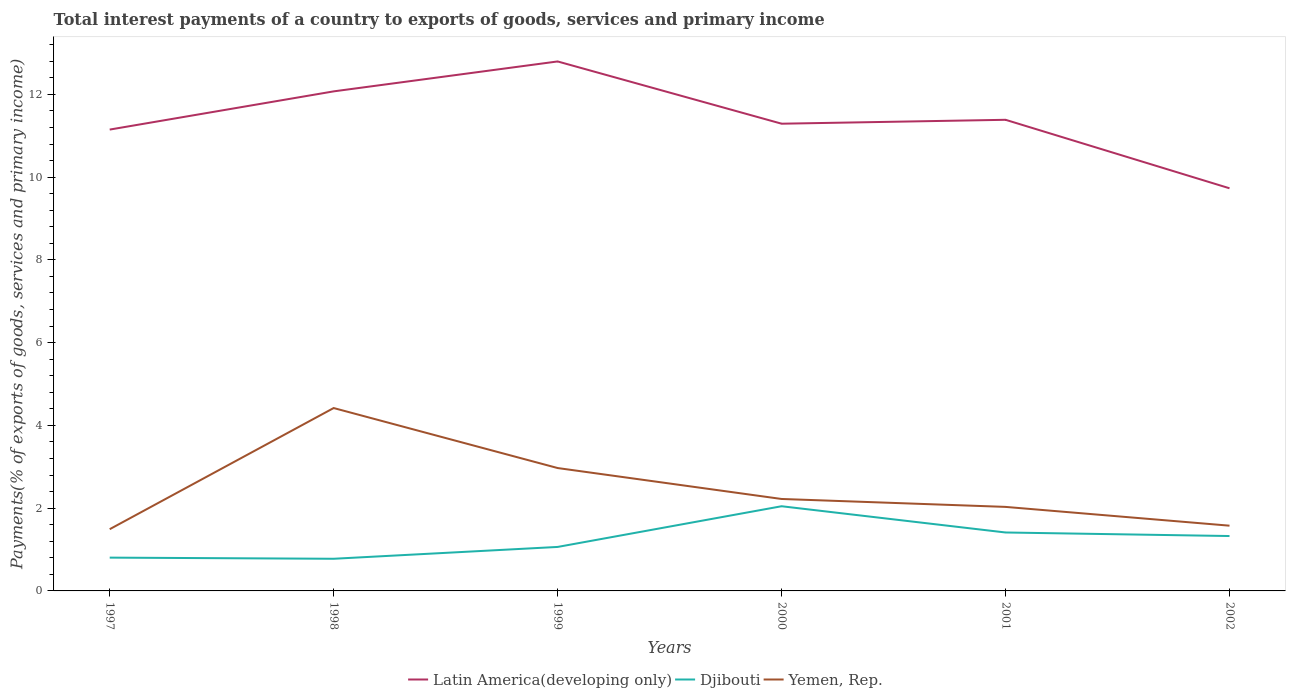Across all years, what is the maximum total interest payments in Latin America(developing only)?
Give a very brief answer. 9.73. What is the total total interest payments in Latin America(developing only) in the graph?
Provide a short and direct response. 1.42. What is the difference between the highest and the second highest total interest payments in Yemen, Rep.?
Your response must be concise. 2.93. How many lines are there?
Your answer should be very brief. 3. How many years are there in the graph?
Your answer should be very brief. 6. Does the graph contain any zero values?
Give a very brief answer. No. Does the graph contain grids?
Provide a succinct answer. No. How many legend labels are there?
Keep it short and to the point. 3. How are the legend labels stacked?
Give a very brief answer. Horizontal. What is the title of the graph?
Offer a very short reply. Total interest payments of a country to exports of goods, services and primary income. Does "Jordan" appear as one of the legend labels in the graph?
Your response must be concise. No. What is the label or title of the X-axis?
Ensure brevity in your answer.  Years. What is the label or title of the Y-axis?
Your answer should be compact. Payments(% of exports of goods, services and primary income). What is the Payments(% of exports of goods, services and primary income) in Latin America(developing only) in 1997?
Provide a short and direct response. 11.15. What is the Payments(% of exports of goods, services and primary income) in Djibouti in 1997?
Provide a succinct answer. 0.8. What is the Payments(% of exports of goods, services and primary income) in Yemen, Rep. in 1997?
Your response must be concise. 1.49. What is the Payments(% of exports of goods, services and primary income) in Latin America(developing only) in 1998?
Provide a short and direct response. 12.07. What is the Payments(% of exports of goods, services and primary income) in Djibouti in 1998?
Offer a very short reply. 0.78. What is the Payments(% of exports of goods, services and primary income) of Yemen, Rep. in 1998?
Make the answer very short. 4.42. What is the Payments(% of exports of goods, services and primary income) of Latin America(developing only) in 1999?
Offer a very short reply. 12.8. What is the Payments(% of exports of goods, services and primary income) of Djibouti in 1999?
Your answer should be compact. 1.06. What is the Payments(% of exports of goods, services and primary income) of Yemen, Rep. in 1999?
Provide a succinct answer. 2.97. What is the Payments(% of exports of goods, services and primary income) in Latin America(developing only) in 2000?
Provide a succinct answer. 11.29. What is the Payments(% of exports of goods, services and primary income) in Djibouti in 2000?
Provide a short and direct response. 2.05. What is the Payments(% of exports of goods, services and primary income) of Yemen, Rep. in 2000?
Offer a very short reply. 2.22. What is the Payments(% of exports of goods, services and primary income) of Latin America(developing only) in 2001?
Your answer should be compact. 11.39. What is the Payments(% of exports of goods, services and primary income) of Djibouti in 2001?
Offer a very short reply. 1.41. What is the Payments(% of exports of goods, services and primary income) of Yemen, Rep. in 2001?
Make the answer very short. 2.03. What is the Payments(% of exports of goods, services and primary income) of Latin America(developing only) in 2002?
Make the answer very short. 9.73. What is the Payments(% of exports of goods, services and primary income) of Djibouti in 2002?
Your response must be concise. 1.33. What is the Payments(% of exports of goods, services and primary income) of Yemen, Rep. in 2002?
Offer a very short reply. 1.58. Across all years, what is the maximum Payments(% of exports of goods, services and primary income) of Latin America(developing only)?
Give a very brief answer. 12.8. Across all years, what is the maximum Payments(% of exports of goods, services and primary income) in Djibouti?
Your answer should be very brief. 2.05. Across all years, what is the maximum Payments(% of exports of goods, services and primary income) of Yemen, Rep.?
Offer a terse response. 4.42. Across all years, what is the minimum Payments(% of exports of goods, services and primary income) in Latin America(developing only)?
Offer a very short reply. 9.73. Across all years, what is the minimum Payments(% of exports of goods, services and primary income) of Djibouti?
Keep it short and to the point. 0.78. Across all years, what is the minimum Payments(% of exports of goods, services and primary income) of Yemen, Rep.?
Keep it short and to the point. 1.49. What is the total Payments(% of exports of goods, services and primary income) of Latin America(developing only) in the graph?
Provide a short and direct response. 68.42. What is the total Payments(% of exports of goods, services and primary income) in Djibouti in the graph?
Give a very brief answer. 7.43. What is the total Payments(% of exports of goods, services and primary income) of Yemen, Rep. in the graph?
Provide a short and direct response. 14.71. What is the difference between the Payments(% of exports of goods, services and primary income) in Latin America(developing only) in 1997 and that in 1998?
Make the answer very short. -0.92. What is the difference between the Payments(% of exports of goods, services and primary income) of Djibouti in 1997 and that in 1998?
Ensure brevity in your answer.  0.03. What is the difference between the Payments(% of exports of goods, services and primary income) of Yemen, Rep. in 1997 and that in 1998?
Make the answer very short. -2.93. What is the difference between the Payments(% of exports of goods, services and primary income) of Latin America(developing only) in 1997 and that in 1999?
Provide a short and direct response. -1.65. What is the difference between the Payments(% of exports of goods, services and primary income) in Djibouti in 1997 and that in 1999?
Provide a short and direct response. -0.26. What is the difference between the Payments(% of exports of goods, services and primary income) of Yemen, Rep. in 1997 and that in 1999?
Offer a terse response. -1.48. What is the difference between the Payments(% of exports of goods, services and primary income) in Latin America(developing only) in 1997 and that in 2000?
Provide a short and direct response. -0.14. What is the difference between the Payments(% of exports of goods, services and primary income) in Djibouti in 1997 and that in 2000?
Your response must be concise. -1.24. What is the difference between the Payments(% of exports of goods, services and primary income) in Yemen, Rep. in 1997 and that in 2000?
Your answer should be compact. -0.73. What is the difference between the Payments(% of exports of goods, services and primary income) of Latin America(developing only) in 1997 and that in 2001?
Make the answer very short. -0.24. What is the difference between the Payments(% of exports of goods, services and primary income) in Djibouti in 1997 and that in 2001?
Give a very brief answer. -0.61. What is the difference between the Payments(% of exports of goods, services and primary income) of Yemen, Rep. in 1997 and that in 2001?
Provide a succinct answer. -0.54. What is the difference between the Payments(% of exports of goods, services and primary income) in Latin America(developing only) in 1997 and that in 2002?
Keep it short and to the point. 1.42. What is the difference between the Payments(% of exports of goods, services and primary income) in Djibouti in 1997 and that in 2002?
Ensure brevity in your answer.  -0.52. What is the difference between the Payments(% of exports of goods, services and primary income) of Yemen, Rep. in 1997 and that in 2002?
Your answer should be very brief. -0.08. What is the difference between the Payments(% of exports of goods, services and primary income) of Latin America(developing only) in 1998 and that in 1999?
Give a very brief answer. -0.72. What is the difference between the Payments(% of exports of goods, services and primary income) in Djibouti in 1998 and that in 1999?
Your answer should be very brief. -0.29. What is the difference between the Payments(% of exports of goods, services and primary income) in Yemen, Rep. in 1998 and that in 1999?
Your response must be concise. 1.45. What is the difference between the Payments(% of exports of goods, services and primary income) in Latin America(developing only) in 1998 and that in 2000?
Your response must be concise. 0.78. What is the difference between the Payments(% of exports of goods, services and primary income) in Djibouti in 1998 and that in 2000?
Your response must be concise. -1.27. What is the difference between the Payments(% of exports of goods, services and primary income) in Yemen, Rep. in 1998 and that in 2000?
Offer a very short reply. 2.2. What is the difference between the Payments(% of exports of goods, services and primary income) of Latin America(developing only) in 1998 and that in 2001?
Your response must be concise. 0.69. What is the difference between the Payments(% of exports of goods, services and primary income) of Djibouti in 1998 and that in 2001?
Your answer should be very brief. -0.64. What is the difference between the Payments(% of exports of goods, services and primary income) in Yemen, Rep. in 1998 and that in 2001?
Your response must be concise. 2.39. What is the difference between the Payments(% of exports of goods, services and primary income) of Latin America(developing only) in 1998 and that in 2002?
Your response must be concise. 2.34. What is the difference between the Payments(% of exports of goods, services and primary income) of Djibouti in 1998 and that in 2002?
Make the answer very short. -0.55. What is the difference between the Payments(% of exports of goods, services and primary income) in Yemen, Rep. in 1998 and that in 2002?
Your answer should be very brief. 2.84. What is the difference between the Payments(% of exports of goods, services and primary income) in Latin America(developing only) in 1999 and that in 2000?
Keep it short and to the point. 1.5. What is the difference between the Payments(% of exports of goods, services and primary income) of Djibouti in 1999 and that in 2000?
Your answer should be very brief. -0.98. What is the difference between the Payments(% of exports of goods, services and primary income) in Yemen, Rep. in 1999 and that in 2000?
Make the answer very short. 0.75. What is the difference between the Payments(% of exports of goods, services and primary income) in Latin America(developing only) in 1999 and that in 2001?
Provide a short and direct response. 1.41. What is the difference between the Payments(% of exports of goods, services and primary income) of Djibouti in 1999 and that in 2001?
Provide a succinct answer. -0.35. What is the difference between the Payments(% of exports of goods, services and primary income) of Yemen, Rep. in 1999 and that in 2001?
Your answer should be very brief. 0.94. What is the difference between the Payments(% of exports of goods, services and primary income) in Latin America(developing only) in 1999 and that in 2002?
Give a very brief answer. 3.07. What is the difference between the Payments(% of exports of goods, services and primary income) of Djibouti in 1999 and that in 2002?
Offer a terse response. -0.26. What is the difference between the Payments(% of exports of goods, services and primary income) in Yemen, Rep. in 1999 and that in 2002?
Offer a terse response. 1.39. What is the difference between the Payments(% of exports of goods, services and primary income) of Latin America(developing only) in 2000 and that in 2001?
Provide a succinct answer. -0.09. What is the difference between the Payments(% of exports of goods, services and primary income) of Djibouti in 2000 and that in 2001?
Offer a terse response. 0.63. What is the difference between the Payments(% of exports of goods, services and primary income) of Yemen, Rep. in 2000 and that in 2001?
Provide a succinct answer. 0.19. What is the difference between the Payments(% of exports of goods, services and primary income) in Latin America(developing only) in 2000 and that in 2002?
Make the answer very short. 1.56. What is the difference between the Payments(% of exports of goods, services and primary income) of Djibouti in 2000 and that in 2002?
Provide a succinct answer. 0.72. What is the difference between the Payments(% of exports of goods, services and primary income) in Yemen, Rep. in 2000 and that in 2002?
Your response must be concise. 0.65. What is the difference between the Payments(% of exports of goods, services and primary income) in Latin America(developing only) in 2001 and that in 2002?
Give a very brief answer. 1.66. What is the difference between the Payments(% of exports of goods, services and primary income) of Djibouti in 2001 and that in 2002?
Your answer should be compact. 0.09. What is the difference between the Payments(% of exports of goods, services and primary income) of Yemen, Rep. in 2001 and that in 2002?
Provide a short and direct response. 0.45. What is the difference between the Payments(% of exports of goods, services and primary income) in Latin America(developing only) in 1997 and the Payments(% of exports of goods, services and primary income) in Djibouti in 1998?
Make the answer very short. 10.37. What is the difference between the Payments(% of exports of goods, services and primary income) in Latin America(developing only) in 1997 and the Payments(% of exports of goods, services and primary income) in Yemen, Rep. in 1998?
Offer a very short reply. 6.73. What is the difference between the Payments(% of exports of goods, services and primary income) of Djibouti in 1997 and the Payments(% of exports of goods, services and primary income) of Yemen, Rep. in 1998?
Your answer should be compact. -3.61. What is the difference between the Payments(% of exports of goods, services and primary income) in Latin America(developing only) in 1997 and the Payments(% of exports of goods, services and primary income) in Djibouti in 1999?
Provide a succinct answer. 10.09. What is the difference between the Payments(% of exports of goods, services and primary income) in Latin America(developing only) in 1997 and the Payments(% of exports of goods, services and primary income) in Yemen, Rep. in 1999?
Give a very brief answer. 8.18. What is the difference between the Payments(% of exports of goods, services and primary income) in Djibouti in 1997 and the Payments(% of exports of goods, services and primary income) in Yemen, Rep. in 1999?
Give a very brief answer. -2.16. What is the difference between the Payments(% of exports of goods, services and primary income) in Latin America(developing only) in 1997 and the Payments(% of exports of goods, services and primary income) in Djibouti in 2000?
Keep it short and to the point. 9.1. What is the difference between the Payments(% of exports of goods, services and primary income) in Latin America(developing only) in 1997 and the Payments(% of exports of goods, services and primary income) in Yemen, Rep. in 2000?
Give a very brief answer. 8.93. What is the difference between the Payments(% of exports of goods, services and primary income) of Djibouti in 1997 and the Payments(% of exports of goods, services and primary income) of Yemen, Rep. in 2000?
Offer a terse response. -1.42. What is the difference between the Payments(% of exports of goods, services and primary income) in Latin America(developing only) in 1997 and the Payments(% of exports of goods, services and primary income) in Djibouti in 2001?
Give a very brief answer. 9.74. What is the difference between the Payments(% of exports of goods, services and primary income) in Latin America(developing only) in 1997 and the Payments(% of exports of goods, services and primary income) in Yemen, Rep. in 2001?
Give a very brief answer. 9.12. What is the difference between the Payments(% of exports of goods, services and primary income) in Djibouti in 1997 and the Payments(% of exports of goods, services and primary income) in Yemen, Rep. in 2001?
Make the answer very short. -1.23. What is the difference between the Payments(% of exports of goods, services and primary income) of Latin America(developing only) in 1997 and the Payments(% of exports of goods, services and primary income) of Djibouti in 2002?
Your answer should be very brief. 9.82. What is the difference between the Payments(% of exports of goods, services and primary income) in Latin America(developing only) in 1997 and the Payments(% of exports of goods, services and primary income) in Yemen, Rep. in 2002?
Provide a short and direct response. 9.57. What is the difference between the Payments(% of exports of goods, services and primary income) in Djibouti in 1997 and the Payments(% of exports of goods, services and primary income) in Yemen, Rep. in 2002?
Offer a terse response. -0.77. What is the difference between the Payments(% of exports of goods, services and primary income) in Latin America(developing only) in 1998 and the Payments(% of exports of goods, services and primary income) in Djibouti in 1999?
Keep it short and to the point. 11.01. What is the difference between the Payments(% of exports of goods, services and primary income) of Latin America(developing only) in 1998 and the Payments(% of exports of goods, services and primary income) of Yemen, Rep. in 1999?
Give a very brief answer. 9.1. What is the difference between the Payments(% of exports of goods, services and primary income) of Djibouti in 1998 and the Payments(% of exports of goods, services and primary income) of Yemen, Rep. in 1999?
Offer a terse response. -2.19. What is the difference between the Payments(% of exports of goods, services and primary income) in Latin America(developing only) in 1998 and the Payments(% of exports of goods, services and primary income) in Djibouti in 2000?
Your answer should be very brief. 10.03. What is the difference between the Payments(% of exports of goods, services and primary income) of Latin America(developing only) in 1998 and the Payments(% of exports of goods, services and primary income) of Yemen, Rep. in 2000?
Make the answer very short. 9.85. What is the difference between the Payments(% of exports of goods, services and primary income) of Djibouti in 1998 and the Payments(% of exports of goods, services and primary income) of Yemen, Rep. in 2000?
Keep it short and to the point. -1.45. What is the difference between the Payments(% of exports of goods, services and primary income) of Latin America(developing only) in 1998 and the Payments(% of exports of goods, services and primary income) of Djibouti in 2001?
Offer a terse response. 10.66. What is the difference between the Payments(% of exports of goods, services and primary income) in Latin America(developing only) in 1998 and the Payments(% of exports of goods, services and primary income) in Yemen, Rep. in 2001?
Make the answer very short. 10.04. What is the difference between the Payments(% of exports of goods, services and primary income) of Djibouti in 1998 and the Payments(% of exports of goods, services and primary income) of Yemen, Rep. in 2001?
Your response must be concise. -1.25. What is the difference between the Payments(% of exports of goods, services and primary income) in Latin America(developing only) in 1998 and the Payments(% of exports of goods, services and primary income) in Djibouti in 2002?
Keep it short and to the point. 10.75. What is the difference between the Payments(% of exports of goods, services and primary income) of Latin America(developing only) in 1998 and the Payments(% of exports of goods, services and primary income) of Yemen, Rep. in 2002?
Offer a very short reply. 10.5. What is the difference between the Payments(% of exports of goods, services and primary income) of Djibouti in 1998 and the Payments(% of exports of goods, services and primary income) of Yemen, Rep. in 2002?
Offer a very short reply. -0.8. What is the difference between the Payments(% of exports of goods, services and primary income) of Latin America(developing only) in 1999 and the Payments(% of exports of goods, services and primary income) of Djibouti in 2000?
Make the answer very short. 10.75. What is the difference between the Payments(% of exports of goods, services and primary income) of Latin America(developing only) in 1999 and the Payments(% of exports of goods, services and primary income) of Yemen, Rep. in 2000?
Ensure brevity in your answer.  10.57. What is the difference between the Payments(% of exports of goods, services and primary income) of Djibouti in 1999 and the Payments(% of exports of goods, services and primary income) of Yemen, Rep. in 2000?
Provide a succinct answer. -1.16. What is the difference between the Payments(% of exports of goods, services and primary income) of Latin America(developing only) in 1999 and the Payments(% of exports of goods, services and primary income) of Djibouti in 2001?
Your answer should be very brief. 11.38. What is the difference between the Payments(% of exports of goods, services and primary income) in Latin America(developing only) in 1999 and the Payments(% of exports of goods, services and primary income) in Yemen, Rep. in 2001?
Ensure brevity in your answer.  10.76. What is the difference between the Payments(% of exports of goods, services and primary income) in Djibouti in 1999 and the Payments(% of exports of goods, services and primary income) in Yemen, Rep. in 2001?
Offer a terse response. -0.97. What is the difference between the Payments(% of exports of goods, services and primary income) of Latin America(developing only) in 1999 and the Payments(% of exports of goods, services and primary income) of Djibouti in 2002?
Offer a terse response. 11.47. What is the difference between the Payments(% of exports of goods, services and primary income) of Latin America(developing only) in 1999 and the Payments(% of exports of goods, services and primary income) of Yemen, Rep. in 2002?
Your answer should be very brief. 11.22. What is the difference between the Payments(% of exports of goods, services and primary income) in Djibouti in 1999 and the Payments(% of exports of goods, services and primary income) in Yemen, Rep. in 2002?
Offer a terse response. -0.51. What is the difference between the Payments(% of exports of goods, services and primary income) of Latin America(developing only) in 2000 and the Payments(% of exports of goods, services and primary income) of Djibouti in 2001?
Make the answer very short. 9.88. What is the difference between the Payments(% of exports of goods, services and primary income) of Latin America(developing only) in 2000 and the Payments(% of exports of goods, services and primary income) of Yemen, Rep. in 2001?
Your answer should be compact. 9.26. What is the difference between the Payments(% of exports of goods, services and primary income) in Djibouti in 2000 and the Payments(% of exports of goods, services and primary income) in Yemen, Rep. in 2001?
Offer a terse response. 0.02. What is the difference between the Payments(% of exports of goods, services and primary income) of Latin America(developing only) in 2000 and the Payments(% of exports of goods, services and primary income) of Djibouti in 2002?
Ensure brevity in your answer.  9.96. What is the difference between the Payments(% of exports of goods, services and primary income) in Latin America(developing only) in 2000 and the Payments(% of exports of goods, services and primary income) in Yemen, Rep. in 2002?
Keep it short and to the point. 9.71. What is the difference between the Payments(% of exports of goods, services and primary income) of Djibouti in 2000 and the Payments(% of exports of goods, services and primary income) of Yemen, Rep. in 2002?
Offer a very short reply. 0.47. What is the difference between the Payments(% of exports of goods, services and primary income) of Latin America(developing only) in 2001 and the Payments(% of exports of goods, services and primary income) of Djibouti in 2002?
Your answer should be compact. 10.06. What is the difference between the Payments(% of exports of goods, services and primary income) of Latin America(developing only) in 2001 and the Payments(% of exports of goods, services and primary income) of Yemen, Rep. in 2002?
Provide a short and direct response. 9.81. What is the difference between the Payments(% of exports of goods, services and primary income) in Djibouti in 2001 and the Payments(% of exports of goods, services and primary income) in Yemen, Rep. in 2002?
Give a very brief answer. -0.16. What is the average Payments(% of exports of goods, services and primary income) of Latin America(developing only) per year?
Your answer should be very brief. 11.4. What is the average Payments(% of exports of goods, services and primary income) in Djibouti per year?
Provide a succinct answer. 1.24. What is the average Payments(% of exports of goods, services and primary income) in Yemen, Rep. per year?
Your answer should be very brief. 2.45. In the year 1997, what is the difference between the Payments(% of exports of goods, services and primary income) of Latin America(developing only) and Payments(% of exports of goods, services and primary income) of Djibouti?
Your answer should be very brief. 10.34. In the year 1997, what is the difference between the Payments(% of exports of goods, services and primary income) in Latin America(developing only) and Payments(% of exports of goods, services and primary income) in Yemen, Rep.?
Your answer should be very brief. 9.66. In the year 1997, what is the difference between the Payments(% of exports of goods, services and primary income) in Djibouti and Payments(% of exports of goods, services and primary income) in Yemen, Rep.?
Keep it short and to the point. -0.69. In the year 1998, what is the difference between the Payments(% of exports of goods, services and primary income) in Latin America(developing only) and Payments(% of exports of goods, services and primary income) in Djibouti?
Ensure brevity in your answer.  11.3. In the year 1998, what is the difference between the Payments(% of exports of goods, services and primary income) in Latin America(developing only) and Payments(% of exports of goods, services and primary income) in Yemen, Rep.?
Provide a succinct answer. 7.65. In the year 1998, what is the difference between the Payments(% of exports of goods, services and primary income) in Djibouti and Payments(% of exports of goods, services and primary income) in Yemen, Rep.?
Offer a terse response. -3.64. In the year 1999, what is the difference between the Payments(% of exports of goods, services and primary income) of Latin America(developing only) and Payments(% of exports of goods, services and primary income) of Djibouti?
Give a very brief answer. 11.73. In the year 1999, what is the difference between the Payments(% of exports of goods, services and primary income) in Latin America(developing only) and Payments(% of exports of goods, services and primary income) in Yemen, Rep.?
Give a very brief answer. 9.83. In the year 1999, what is the difference between the Payments(% of exports of goods, services and primary income) in Djibouti and Payments(% of exports of goods, services and primary income) in Yemen, Rep.?
Offer a terse response. -1.91. In the year 2000, what is the difference between the Payments(% of exports of goods, services and primary income) of Latin America(developing only) and Payments(% of exports of goods, services and primary income) of Djibouti?
Ensure brevity in your answer.  9.24. In the year 2000, what is the difference between the Payments(% of exports of goods, services and primary income) in Latin America(developing only) and Payments(% of exports of goods, services and primary income) in Yemen, Rep.?
Offer a terse response. 9.07. In the year 2000, what is the difference between the Payments(% of exports of goods, services and primary income) of Djibouti and Payments(% of exports of goods, services and primary income) of Yemen, Rep.?
Keep it short and to the point. -0.18. In the year 2001, what is the difference between the Payments(% of exports of goods, services and primary income) of Latin America(developing only) and Payments(% of exports of goods, services and primary income) of Djibouti?
Your answer should be compact. 9.97. In the year 2001, what is the difference between the Payments(% of exports of goods, services and primary income) in Latin America(developing only) and Payments(% of exports of goods, services and primary income) in Yemen, Rep.?
Your response must be concise. 9.35. In the year 2001, what is the difference between the Payments(% of exports of goods, services and primary income) in Djibouti and Payments(% of exports of goods, services and primary income) in Yemen, Rep.?
Give a very brief answer. -0.62. In the year 2002, what is the difference between the Payments(% of exports of goods, services and primary income) of Latin America(developing only) and Payments(% of exports of goods, services and primary income) of Djibouti?
Your answer should be very brief. 8.4. In the year 2002, what is the difference between the Payments(% of exports of goods, services and primary income) in Latin America(developing only) and Payments(% of exports of goods, services and primary income) in Yemen, Rep.?
Offer a terse response. 8.15. In the year 2002, what is the difference between the Payments(% of exports of goods, services and primary income) of Djibouti and Payments(% of exports of goods, services and primary income) of Yemen, Rep.?
Provide a succinct answer. -0.25. What is the ratio of the Payments(% of exports of goods, services and primary income) of Latin America(developing only) in 1997 to that in 1998?
Offer a very short reply. 0.92. What is the ratio of the Payments(% of exports of goods, services and primary income) of Djibouti in 1997 to that in 1998?
Offer a terse response. 1.04. What is the ratio of the Payments(% of exports of goods, services and primary income) of Yemen, Rep. in 1997 to that in 1998?
Offer a terse response. 0.34. What is the ratio of the Payments(% of exports of goods, services and primary income) in Latin America(developing only) in 1997 to that in 1999?
Ensure brevity in your answer.  0.87. What is the ratio of the Payments(% of exports of goods, services and primary income) of Djibouti in 1997 to that in 1999?
Keep it short and to the point. 0.76. What is the ratio of the Payments(% of exports of goods, services and primary income) in Yemen, Rep. in 1997 to that in 1999?
Keep it short and to the point. 0.5. What is the ratio of the Payments(% of exports of goods, services and primary income) of Latin America(developing only) in 1997 to that in 2000?
Offer a terse response. 0.99. What is the ratio of the Payments(% of exports of goods, services and primary income) of Djibouti in 1997 to that in 2000?
Offer a terse response. 0.39. What is the ratio of the Payments(% of exports of goods, services and primary income) of Yemen, Rep. in 1997 to that in 2000?
Offer a terse response. 0.67. What is the ratio of the Payments(% of exports of goods, services and primary income) in Latin America(developing only) in 1997 to that in 2001?
Provide a succinct answer. 0.98. What is the ratio of the Payments(% of exports of goods, services and primary income) of Djibouti in 1997 to that in 2001?
Provide a succinct answer. 0.57. What is the ratio of the Payments(% of exports of goods, services and primary income) of Yemen, Rep. in 1997 to that in 2001?
Ensure brevity in your answer.  0.73. What is the ratio of the Payments(% of exports of goods, services and primary income) in Latin America(developing only) in 1997 to that in 2002?
Provide a succinct answer. 1.15. What is the ratio of the Payments(% of exports of goods, services and primary income) in Djibouti in 1997 to that in 2002?
Your answer should be very brief. 0.61. What is the ratio of the Payments(% of exports of goods, services and primary income) in Yemen, Rep. in 1997 to that in 2002?
Provide a short and direct response. 0.95. What is the ratio of the Payments(% of exports of goods, services and primary income) of Latin America(developing only) in 1998 to that in 1999?
Give a very brief answer. 0.94. What is the ratio of the Payments(% of exports of goods, services and primary income) of Djibouti in 1998 to that in 1999?
Your answer should be compact. 0.73. What is the ratio of the Payments(% of exports of goods, services and primary income) in Yemen, Rep. in 1998 to that in 1999?
Ensure brevity in your answer.  1.49. What is the ratio of the Payments(% of exports of goods, services and primary income) in Latin America(developing only) in 1998 to that in 2000?
Your answer should be compact. 1.07. What is the ratio of the Payments(% of exports of goods, services and primary income) of Djibouti in 1998 to that in 2000?
Provide a short and direct response. 0.38. What is the ratio of the Payments(% of exports of goods, services and primary income) in Yemen, Rep. in 1998 to that in 2000?
Give a very brief answer. 1.99. What is the ratio of the Payments(% of exports of goods, services and primary income) in Latin America(developing only) in 1998 to that in 2001?
Offer a terse response. 1.06. What is the ratio of the Payments(% of exports of goods, services and primary income) in Djibouti in 1998 to that in 2001?
Offer a terse response. 0.55. What is the ratio of the Payments(% of exports of goods, services and primary income) of Yemen, Rep. in 1998 to that in 2001?
Keep it short and to the point. 2.18. What is the ratio of the Payments(% of exports of goods, services and primary income) of Latin America(developing only) in 1998 to that in 2002?
Your answer should be very brief. 1.24. What is the ratio of the Payments(% of exports of goods, services and primary income) in Djibouti in 1998 to that in 2002?
Provide a short and direct response. 0.59. What is the ratio of the Payments(% of exports of goods, services and primary income) of Yemen, Rep. in 1998 to that in 2002?
Provide a short and direct response. 2.8. What is the ratio of the Payments(% of exports of goods, services and primary income) of Latin America(developing only) in 1999 to that in 2000?
Offer a terse response. 1.13. What is the ratio of the Payments(% of exports of goods, services and primary income) in Djibouti in 1999 to that in 2000?
Your response must be concise. 0.52. What is the ratio of the Payments(% of exports of goods, services and primary income) of Yemen, Rep. in 1999 to that in 2000?
Ensure brevity in your answer.  1.34. What is the ratio of the Payments(% of exports of goods, services and primary income) of Latin America(developing only) in 1999 to that in 2001?
Your answer should be compact. 1.12. What is the ratio of the Payments(% of exports of goods, services and primary income) in Djibouti in 1999 to that in 2001?
Offer a terse response. 0.75. What is the ratio of the Payments(% of exports of goods, services and primary income) of Yemen, Rep. in 1999 to that in 2001?
Provide a succinct answer. 1.46. What is the ratio of the Payments(% of exports of goods, services and primary income) in Latin America(developing only) in 1999 to that in 2002?
Keep it short and to the point. 1.31. What is the ratio of the Payments(% of exports of goods, services and primary income) in Djibouti in 1999 to that in 2002?
Offer a very short reply. 0.8. What is the ratio of the Payments(% of exports of goods, services and primary income) of Yemen, Rep. in 1999 to that in 2002?
Give a very brief answer. 1.88. What is the ratio of the Payments(% of exports of goods, services and primary income) of Latin America(developing only) in 2000 to that in 2001?
Your answer should be very brief. 0.99. What is the ratio of the Payments(% of exports of goods, services and primary income) of Djibouti in 2000 to that in 2001?
Provide a short and direct response. 1.45. What is the ratio of the Payments(% of exports of goods, services and primary income) in Yemen, Rep. in 2000 to that in 2001?
Ensure brevity in your answer.  1.09. What is the ratio of the Payments(% of exports of goods, services and primary income) in Latin America(developing only) in 2000 to that in 2002?
Your answer should be compact. 1.16. What is the ratio of the Payments(% of exports of goods, services and primary income) of Djibouti in 2000 to that in 2002?
Your answer should be very brief. 1.54. What is the ratio of the Payments(% of exports of goods, services and primary income) of Yemen, Rep. in 2000 to that in 2002?
Ensure brevity in your answer.  1.41. What is the ratio of the Payments(% of exports of goods, services and primary income) in Latin America(developing only) in 2001 to that in 2002?
Provide a short and direct response. 1.17. What is the ratio of the Payments(% of exports of goods, services and primary income) of Djibouti in 2001 to that in 2002?
Provide a short and direct response. 1.06. What is the ratio of the Payments(% of exports of goods, services and primary income) in Yemen, Rep. in 2001 to that in 2002?
Offer a very short reply. 1.29. What is the difference between the highest and the second highest Payments(% of exports of goods, services and primary income) of Latin America(developing only)?
Give a very brief answer. 0.72. What is the difference between the highest and the second highest Payments(% of exports of goods, services and primary income) in Djibouti?
Make the answer very short. 0.63. What is the difference between the highest and the second highest Payments(% of exports of goods, services and primary income) of Yemen, Rep.?
Offer a terse response. 1.45. What is the difference between the highest and the lowest Payments(% of exports of goods, services and primary income) of Latin America(developing only)?
Provide a short and direct response. 3.07. What is the difference between the highest and the lowest Payments(% of exports of goods, services and primary income) in Djibouti?
Ensure brevity in your answer.  1.27. What is the difference between the highest and the lowest Payments(% of exports of goods, services and primary income) in Yemen, Rep.?
Provide a short and direct response. 2.93. 